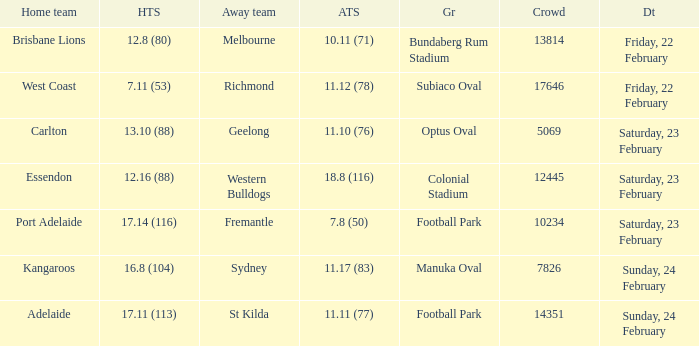Where the home team scored 13.10 (88), what was the size of the crowd? 5069.0. 